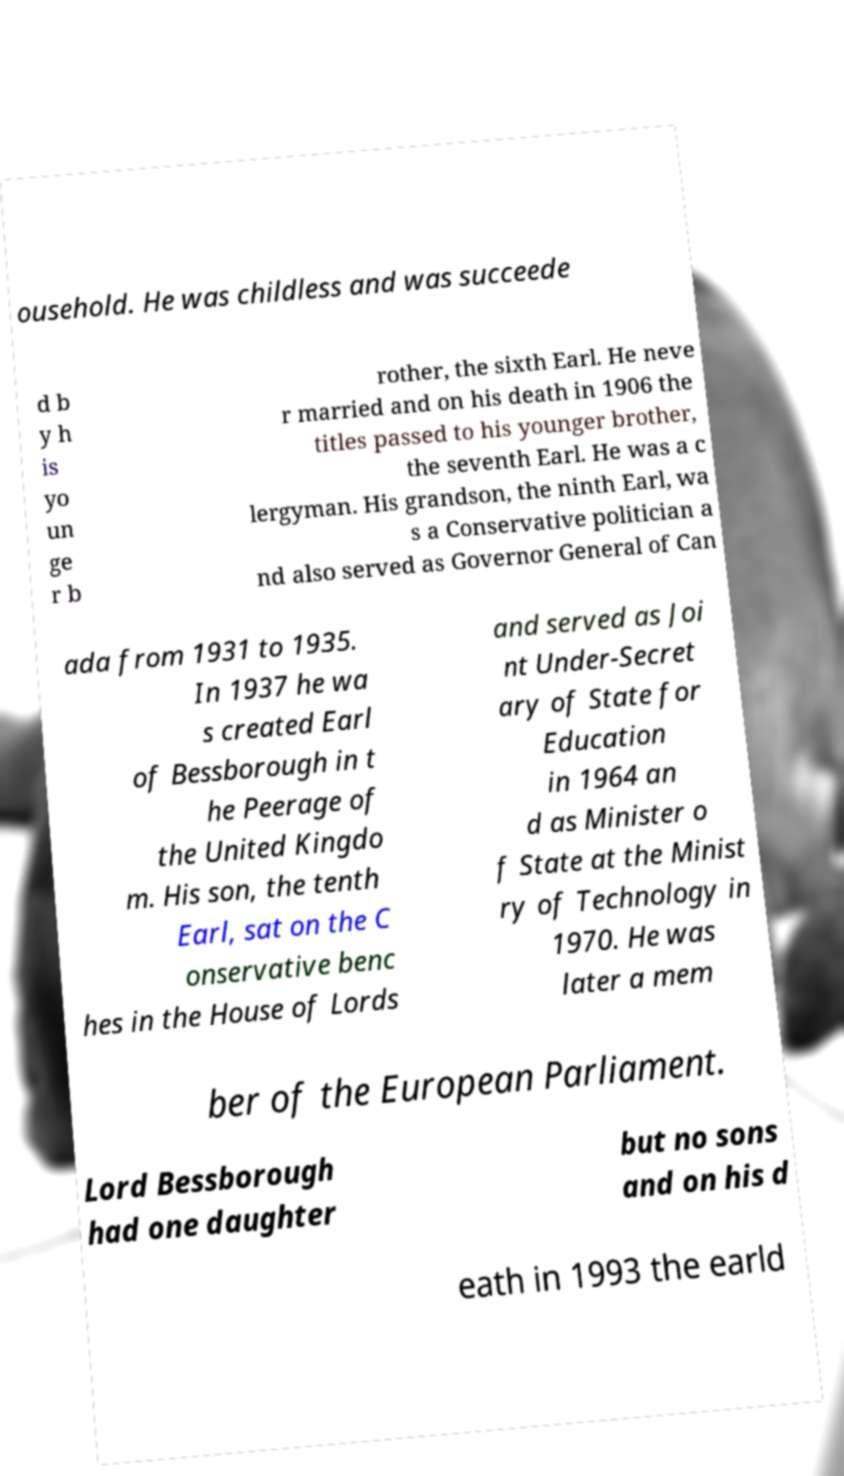Can you read and provide the text displayed in the image?This photo seems to have some interesting text. Can you extract and type it out for me? ousehold. He was childless and was succeede d b y h is yo un ge r b rother, the sixth Earl. He neve r married and on his death in 1906 the titles passed to his younger brother, the seventh Earl. He was a c lergyman. His grandson, the ninth Earl, wa s a Conservative politician a nd also served as Governor General of Can ada from 1931 to 1935. In 1937 he wa s created Earl of Bessborough in t he Peerage of the United Kingdo m. His son, the tenth Earl, sat on the C onservative benc hes in the House of Lords and served as Joi nt Under-Secret ary of State for Education in 1964 an d as Minister o f State at the Minist ry of Technology in 1970. He was later a mem ber of the European Parliament. Lord Bessborough had one daughter but no sons and on his d eath in 1993 the earld 